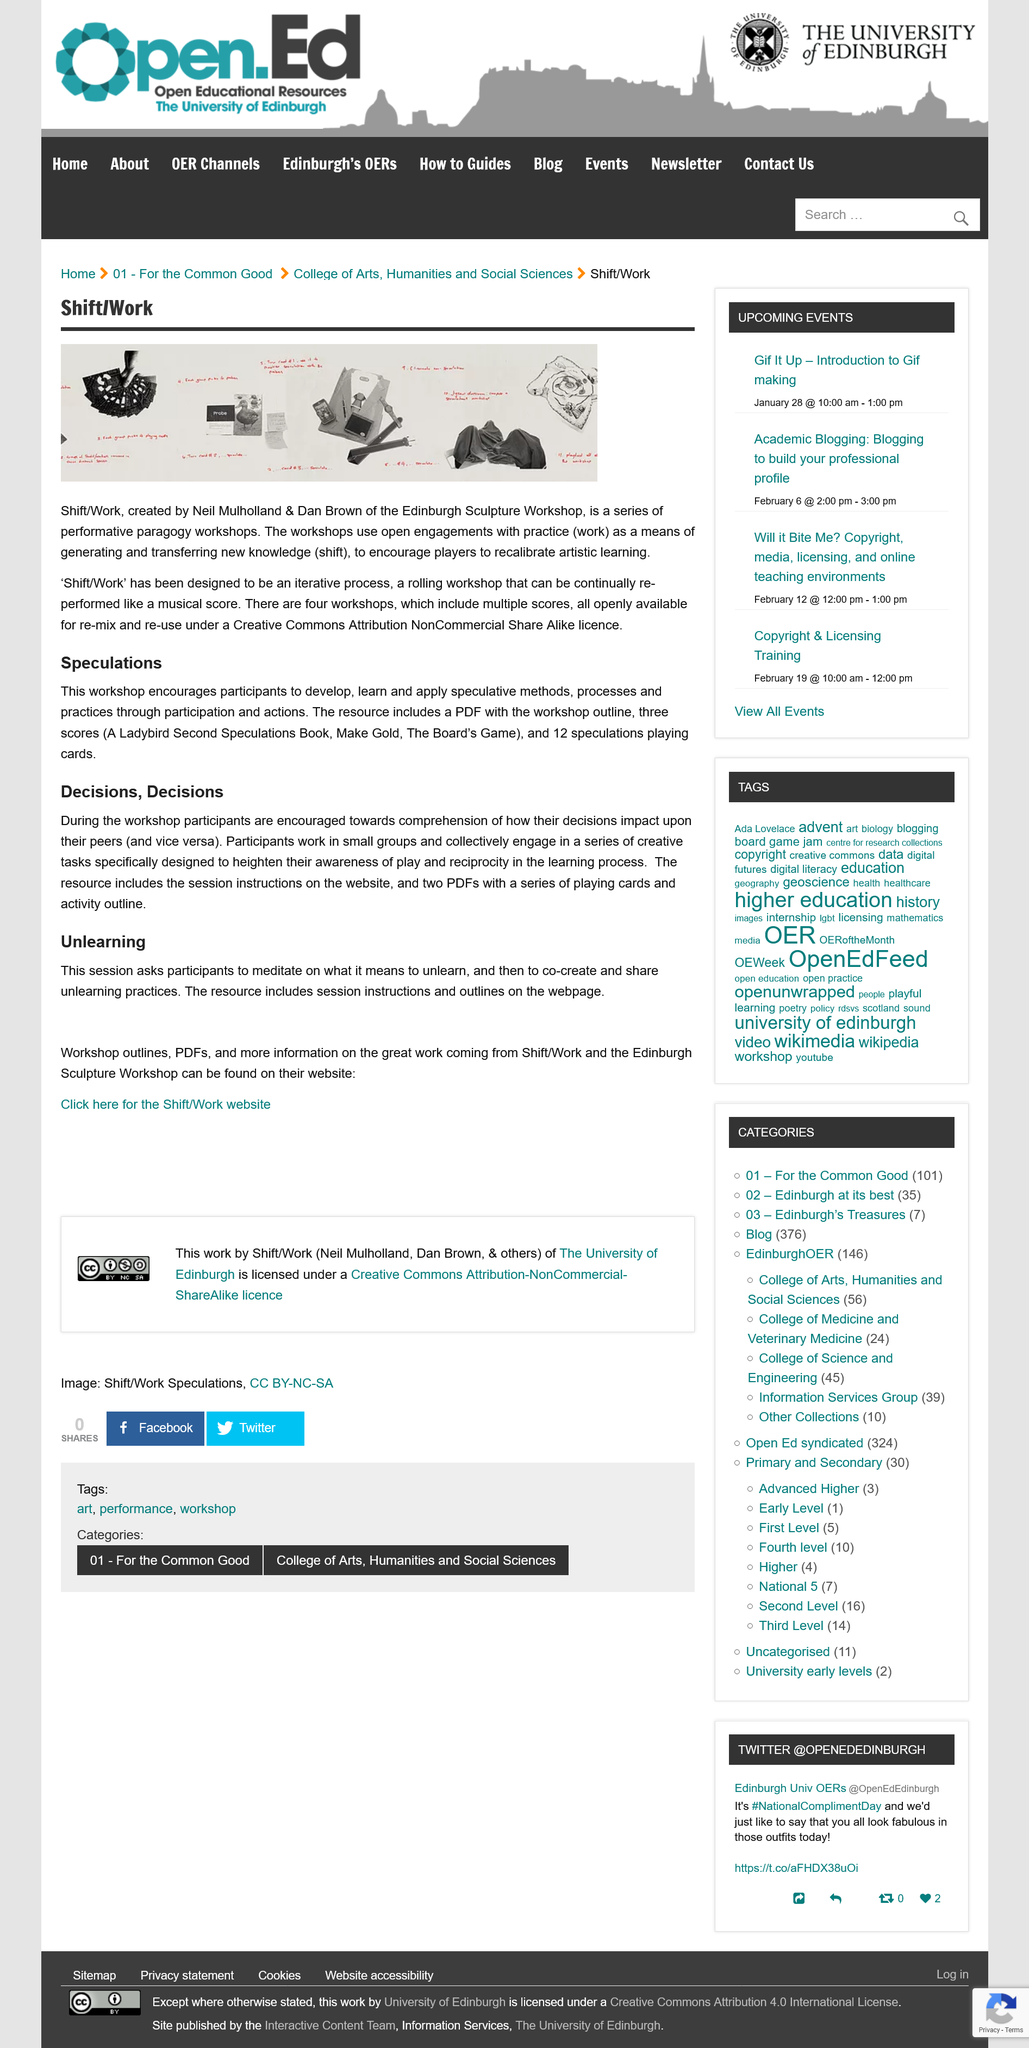Highlight a few significant elements in this photo. Shift/Work is a collection of performative paragogy workshops aimed at enhancing creative expression and critical thinking skills. It is known that Shift/Work was created by Neil Mullholland and Dan Brown. The Shift/Work website provides information on workshop outlines, PDFs, and additional details about the work of Shift/Work and the Edinburgh Sculpture Workshop. The 'Unlearning' workshop session is designed to facilitate reflection and discussion among participants on the concept of unlearning, and to encourage the creation and sharing of unlearning practices. The workshops are called "Shift/Work," and they are designed to help individuals overcome obstacles and achieve their goals. 